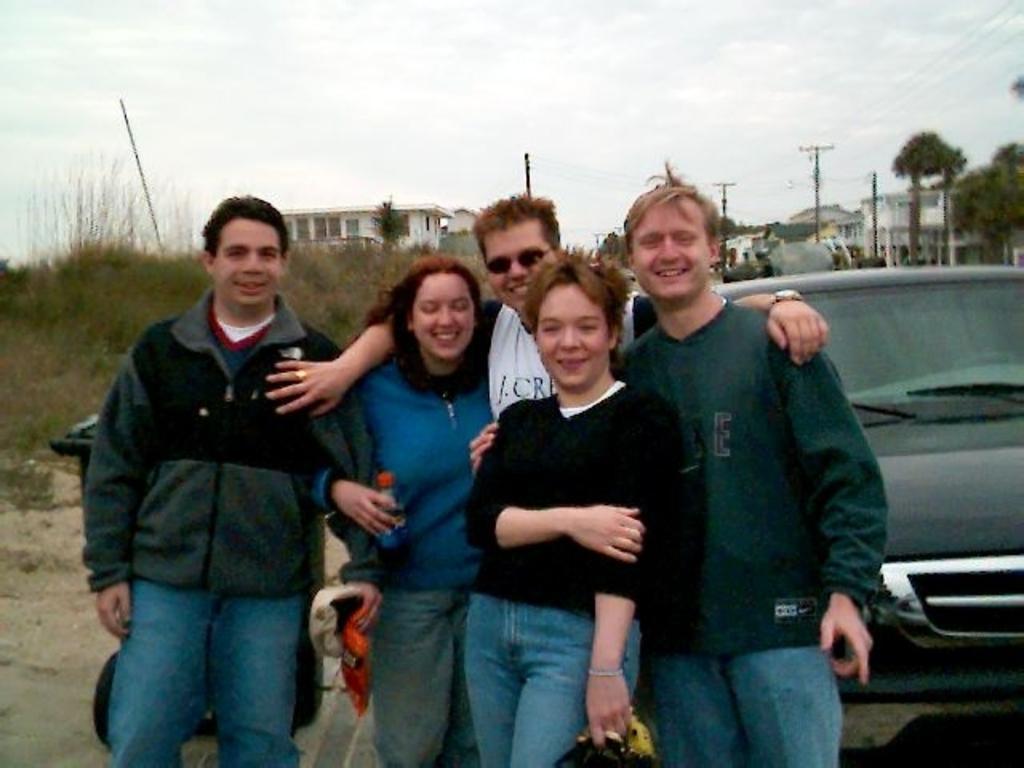Please provide a concise description of this image. As we can see in the image there is a black color car, few people here and there, buildings, trees, current poles and plants. At the top there is sky. 